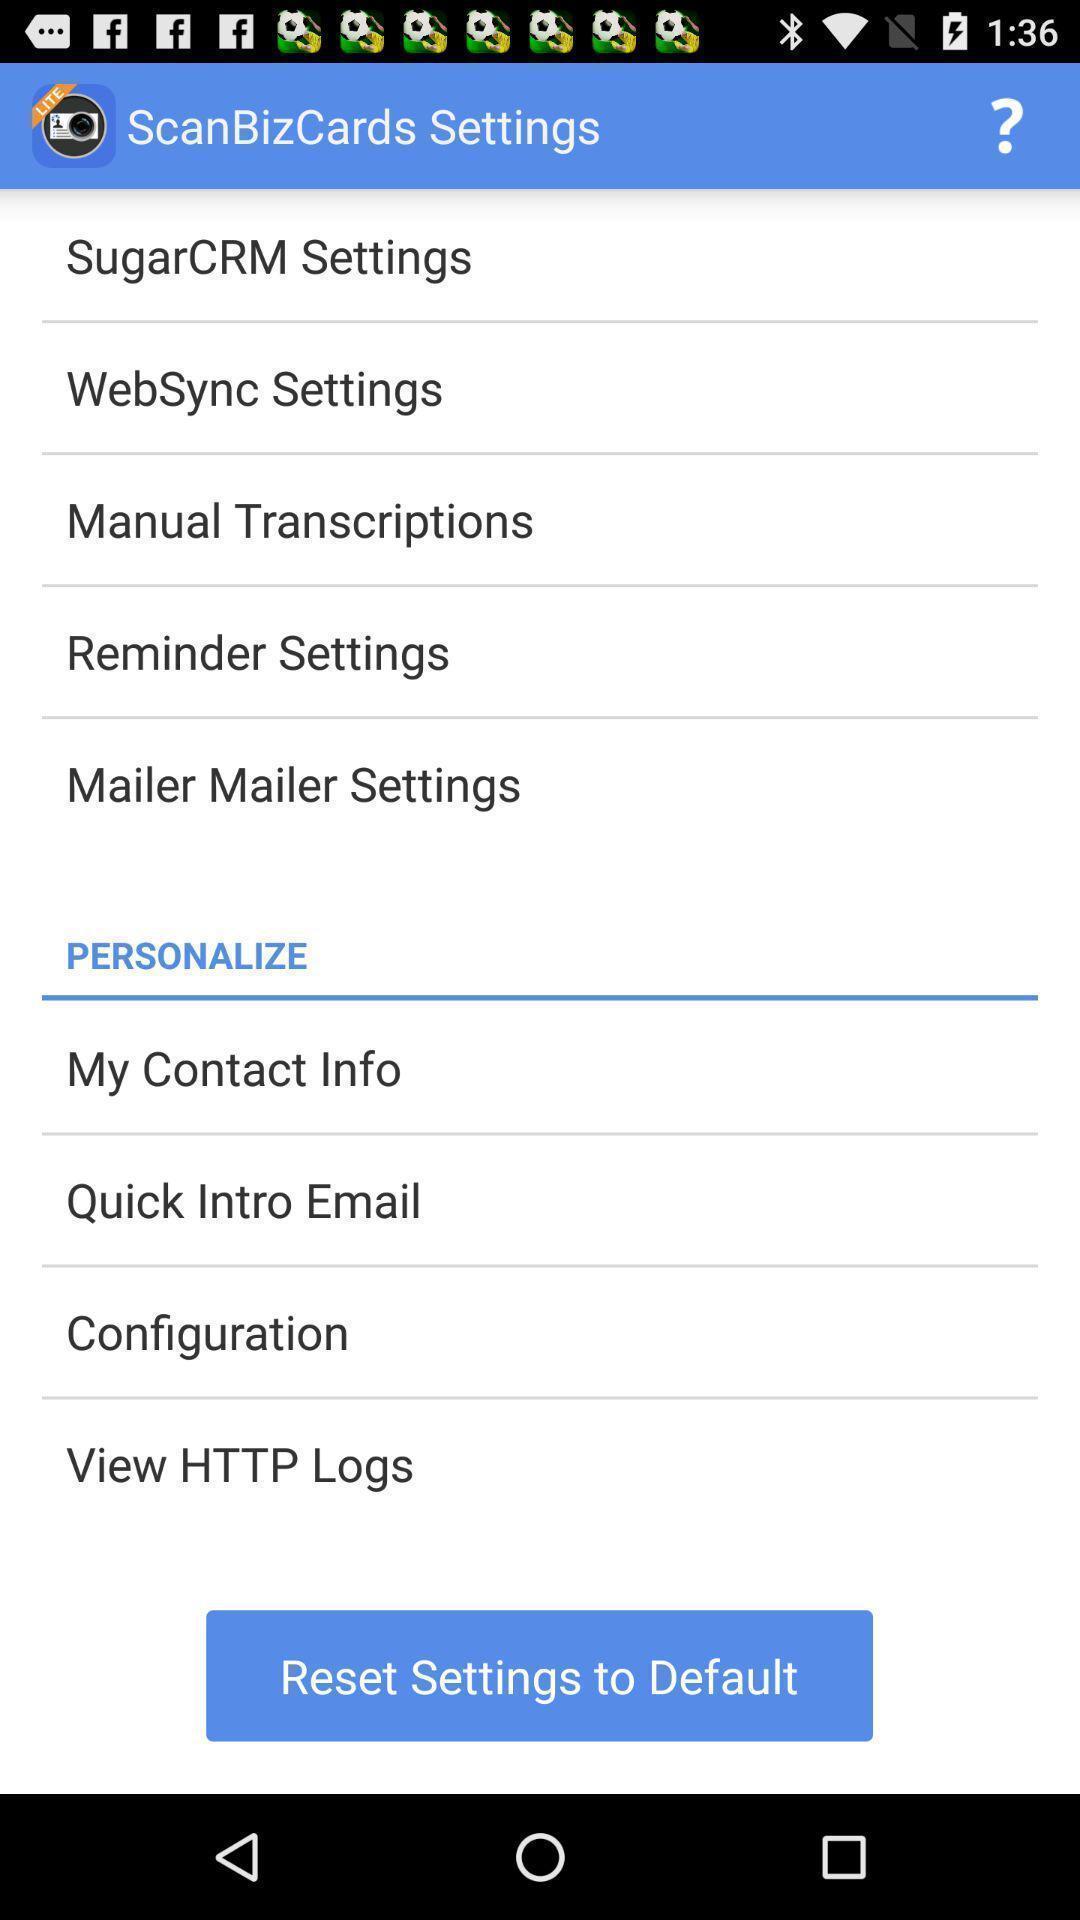Describe the visual elements of this screenshot. Settings page. 